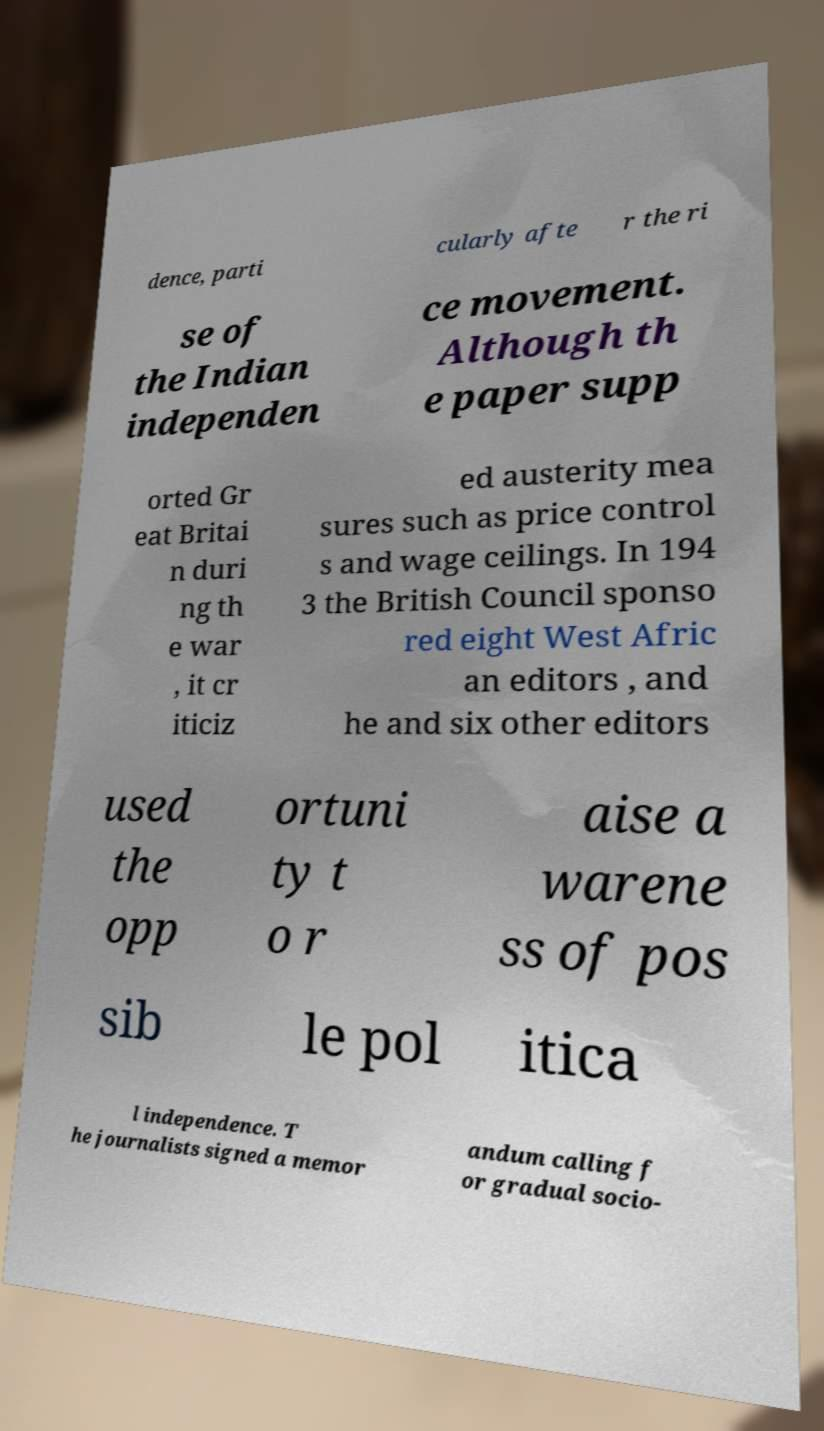There's text embedded in this image that I need extracted. Can you transcribe it verbatim? dence, parti cularly afte r the ri se of the Indian independen ce movement. Although th e paper supp orted Gr eat Britai n duri ng th e war , it cr iticiz ed austerity mea sures such as price control s and wage ceilings. In 194 3 the British Council sponso red eight West Afric an editors , and he and six other editors used the opp ortuni ty t o r aise a warene ss of pos sib le pol itica l independence. T he journalists signed a memor andum calling f or gradual socio- 